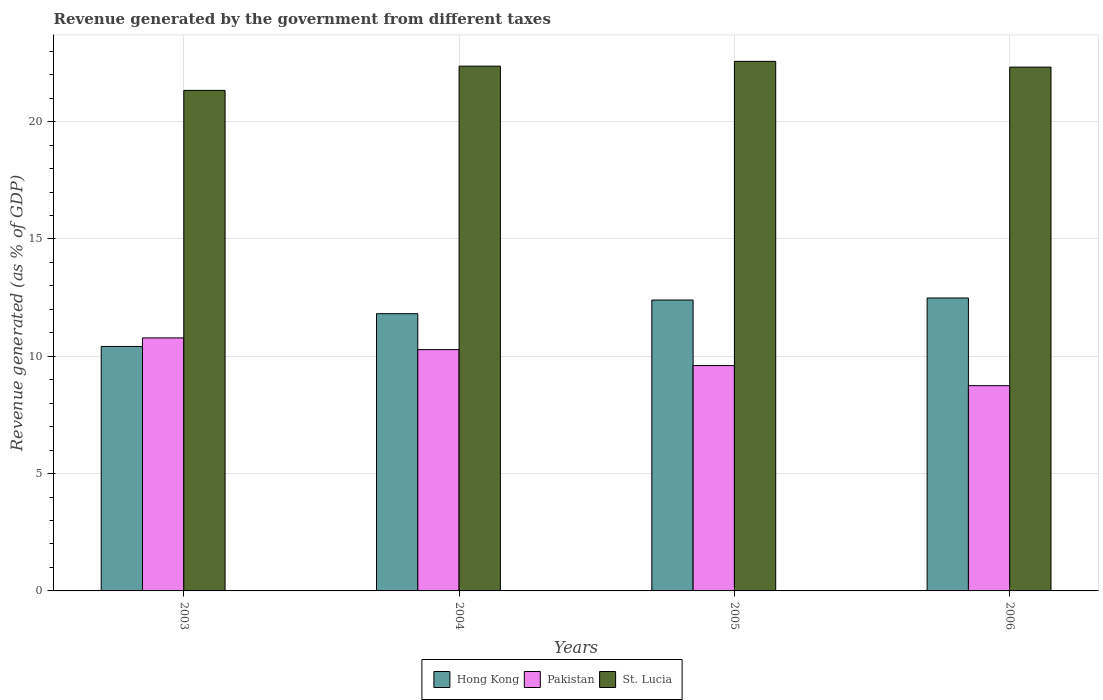Are the number of bars per tick equal to the number of legend labels?
Provide a succinct answer. Yes. Are the number of bars on each tick of the X-axis equal?
Give a very brief answer. Yes. How many bars are there on the 1st tick from the right?
Provide a succinct answer. 3. What is the label of the 2nd group of bars from the left?
Provide a succinct answer. 2004. In how many cases, is the number of bars for a given year not equal to the number of legend labels?
Ensure brevity in your answer.  0. What is the revenue generated by the government in Pakistan in 2003?
Keep it short and to the point. 10.78. Across all years, what is the maximum revenue generated by the government in St. Lucia?
Make the answer very short. 22.57. Across all years, what is the minimum revenue generated by the government in Pakistan?
Offer a very short reply. 8.75. In which year was the revenue generated by the government in Hong Kong maximum?
Your response must be concise. 2006. In which year was the revenue generated by the government in St. Lucia minimum?
Your answer should be very brief. 2003. What is the total revenue generated by the government in Pakistan in the graph?
Give a very brief answer. 39.42. What is the difference between the revenue generated by the government in Pakistan in 2003 and that in 2005?
Give a very brief answer. 1.18. What is the difference between the revenue generated by the government in Hong Kong in 2006 and the revenue generated by the government in Pakistan in 2004?
Offer a terse response. 2.2. What is the average revenue generated by the government in St. Lucia per year?
Provide a succinct answer. 22.15. In the year 2005, what is the difference between the revenue generated by the government in Pakistan and revenue generated by the government in St. Lucia?
Your answer should be very brief. -12.97. What is the ratio of the revenue generated by the government in St. Lucia in 2003 to that in 2005?
Provide a succinct answer. 0.95. Is the difference between the revenue generated by the government in Pakistan in 2005 and 2006 greater than the difference between the revenue generated by the government in St. Lucia in 2005 and 2006?
Offer a very short reply. Yes. What is the difference between the highest and the second highest revenue generated by the government in Hong Kong?
Keep it short and to the point. 0.09. What is the difference between the highest and the lowest revenue generated by the government in Hong Kong?
Provide a short and direct response. 2.07. In how many years, is the revenue generated by the government in Pakistan greater than the average revenue generated by the government in Pakistan taken over all years?
Offer a very short reply. 2. Is the sum of the revenue generated by the government in St. Lucia in 2004 and 2005 greater than the maximum revenue generated by the government in Pakistan across all years?
Provide a short and direct response. Yes. What does the 3rd bar from the left in 2003 represents?
Make the answer very short. St. Lucia. How many bars are there?
Provide a short and direct response. 12. Are the values on the major ticks of Y-axis written in scientific E-notation?
Your answer should be very brief. No. Does the graph contain any zero values?
Ensure brevity in your answer.  No. What is the title of the graph?
Your response must be concise. Revenue generated by the government from different taxes. Does "South Asia" appear as one of the legend labels in the graph?
Provide a succinct answer. No. What is the label or title of the Y-axis?
Your answer should be very brief. Revenue generated (as % of GDP). What is the Revenue generated (as % of GDP) of Hong Kong in 2003?
Provide a succinct answer. 10.42. What is the Revenue generated (as % of GDP) in Pakistan in 2003?
Keep it short and to the point. 10.78. What is the Revenue generated (as % of GDP) in St. Lucia in 2003?
Give a very brief answer. 21.33. What is the Revenue generated (as % of GDP) in Hong Kong in 2004?
Give a very brief answer. 11.82. What is the Revenue generated (as % of GDP) of Pakistan in 2004?
Offer a terse response. 10.28. What is the Revenue generated (as % of GDP) in St. Lucia in 2004?
Provide a succinct answer. 22.37. What is the Revenue generated (as % of GDP) of Hong Kong in 2005?
Provide a short and direct response. 12.4. What is the Revenue generated (as % of GDP) in Pakistan in 2005?
Your answer should be compact. 9.6. What is the Revenue generated (as % of GDP) in St. Lucia in 2005?
Your answer should be compact. 22.57. What is the Revenue generated (as % of GDP) of Hong Kong in 2006?
Offer a terse response. 12.49. What is the Revenue generated (as % of GDP) in Pakistan in 2006?
Offer a terse response. 8.75. What is the Revenue generated (as % of GDP) of St. Lucia in 2006?
Provide a short and direct response. 22.32. Across all years, what is the maximum Revenue generated (as % of GDP) of Hong Kong?
Your answer should be very brief. 12.49. Across all years, what is the maximum Revenue generated (as % of GDP) in Pakistan?
Provide a succinct answer. 10.78. Across all years, what is the maximum Revenue generated (as % of GDP) of St. Lucia?
Ensure brevity in your answer.  22.57. Across all years, what is the minimum Revenue generated (as % of GDP) of Hong Kong?
Your response must be concise. 10.42. Across all years, what is the minimum Revenue generated (as % of GDP) of Pakistan?
Offer a terse response. 8.75. Across all years, what is the minimum Revenue generated (as % of GDP) of St. Lucia?
Your answer should be compact. 21.33. What is the total Revenue generated (as % of GDP) in Hong Kong in the graph?
Ensure brevity in your answer.  47.12. What is the total Revenue generated (as % of GDP) in Pakistan in the graph?
Your answer should be compact. 39.42. What is the total Revenue generated (as % of GDP) of St. Lucia in the graph?
Offer a terse response. 88.59. What is the difference between the Revenue generated (as % of GDP) in Hong Kong in 2003 and that in 2004?
Give a very brief answer. -1.4. What is the difference between the Revenue generated (as % of GDP) in Pakistan in 2003 and that in 2004?
Your response must be concise. 0.5. What is the difference between the Revenue generated (as % of GDP) in St. Lucia in 2003 and that in 2004?
Your response must be concise. -1.03. What is the difference between the Revenue generated (as % of GDP) in Hong Kong in 2003 and that in 2005?
Give a very brief answer. -1.98. What is the difference between the Revenue generated (as % of GDP) in Pakistan in 2003 and that in 2005?
Your response must be concise. 1.18. What is the difference between the Revenue generated (as % of GDP) of St. Lucia in 2003 and that in 2005?
Give a very brief answer. -1.24. What is the difference between the Revenue generated (as % of GDP) in Hong Kong in 2003 and that in 2006?
Make the answer very short. -2.07. What is the difference between the Revenue generated (as % of GDP) of Pakistan in 2003 and that in 2006?
Keep it short and to the point. 2.04. What is the difference between the Revenue generated (as % of GDP) in St. Lucia in 2003 and that in 2006?
Your response must be concise. -0.99. What is the difference between the Revenue generated (as % of GDP) of Hong Kong in 2004 and that in 2005?
Provide a succinct answer. -0.58. What is the difference between the Revenue generated (as % of GDP) in Pakistan in 2004 and that in 2005?
Your answer should be compact. 0.68. What is the difference between the Revenue generated (as % of GDP) of St. Lucia in 2004 and that in 2005?
Your answer should be compact. -0.2. What is the difference between the Revenue generated (as % of GDP) in Hong Kong in 2004 and that in 2006?
Ensure brevity in your answer.  -0.67. What is the difference between the Revenue generated (as % of GDP) of Pakistan in 2004 and that in 2006?
Make the answer very short. 1.54. What is the difference between the Revenue generated (as % of GDP) in St. Lucia in 2004 and that in 2006?
Give a very brief answer. 0.04. What is the difference between the Revenue generated (as % of GDP) of Hong Kong in 2005 and that in 2006?
Make the answer very short. -0.09. What is the difference between the Revenue generated (as % of GDP) of Pakistan in 2005 and that in 2006?
Your response must be concise. 0.86. What is the difference between the Revenue generated (as % of GDP) of St. Lucia in 2005 and that in 2006?
Provide a short and direct response. 0.25. What is the difference between the Revenue generated (as % of GDP) in Hong Kong in 2003 and the Revenue generated (as % of GDP) in Pakistan in 2004?
Give a very brief answer. 0.13. What is the difference between the Revenue generated (as % of GDP) in Hong Kong in 2003 and the Revenue generated (as % of GDP) in St. Lucia in 2004?
Ensure brevity in your answer.  -11.95. What is the difference between the Revenue generated (as % of GDP) in Pakistan in 2003 and the Revenue generated (as % of GDP) in St. Lucia in 2004?
Offer a terse response. -11.58. What is the difference between the Revenue generated (as % of GDP) in Hong Kong in 2003 and the Revenue generated (as % of GDP) in Pakistan in 2005?
Your response must be concise. 0.81. What is the difference between the Revenue generated (as % of GDP) of Hong Kong in 2003 and the Revenue generated (as % of GDP) of St. Lucia in 2005?
Ensure brevity in your answer.  -12.15. What is the difference between the Revenue generated (as % of GDP) of Pakistan in 2003 and the Revenue generated (as % of GDP) of St. Lucia in 2005?
Ensure brevity in your answer.  -11.79. What is the difference between the Revenue generated (as % of GDP) of Hong Kong in 2003 and the Revenue generated (as % of GDP) of Pakistan in 2006?
Keep it short and to the point. 1.67. What is the difference between the Revenue generated (as % of GDP) of Hong Kong in 2003 and the Revenue generated (as % of GDP) of St. Lucia in 2006?
Provide a succinct answer. -11.91. What is the difference between the Revenue generated (as % of GDP) in Pakistan in 2003 and the Revenue generated (as % of GDP) in St. Lucia in 2006?
Offer a terse response. -11.54. What is the difference between the Revenue generated (as % of GDP) of Hong Kong in 2004 and the Revenue generated (as % of GDP) of Pakistan in 2005?
Your answer should be very brief. 2.21. What is the difference between the Revenue generated (as % of GDP) in Hong Kong in 2004 and the Revenue generated (as % of GDP) in St. Lucia in 2005?
Offer a very short reply. -10.75. What is the difference between the Revenue generated (as % of GDP) of Pakistan in 2004 and the Revenue generated (as % of GDP) of St. Lucia in 2005?
Provide a short and direct response. -12.29. What is the difference between the Revenue generated (as % of GDP) in Hong Kong in 2004 and the Revenue generated (as % of GDP) in Pakistan in 2006?
Offer a very short reply. 3.07. What is the difference between the Revenue generated (as % of GDP) of Hong Kong in 2004 and the Revenue generated (as % of GDP) of St. Lucia in 2006?
Your answer should be compact. -10.51. What is the difference between the Revenue generated (as % of GDP) in Pakistan in 2004 and the Revenue generated (as % of GDP) in St. Lucia in 2006?
Give a very brief answer. -12.04. What is the difference between the Revenue generated (as % of GDP) of Hong Kong in 2005 and the Revenue generated (as % of GDP) of Pakistan in 2006?
Keep it short and to the point. 3.65. What is the difference between the Revenue generated (as % of GDP) of Hong Kong in 2005 and the Revenue generated (as % of GDP) of St. Lucia in 2006?
Offer a very short reply. -9.93. What is the difference between the Revenue generated (as % of GDP) in Pakistan in 2005 and the Revenue generated (as % of GDP) in St. Lucia in 2006?
Provide a succinct answer. -12.72. What is the average Revenue generated (as % of GDP) in Hong Kong per year?
Offer a terse response. 11.78. What is the average Revenue generated (as % of GDP) of Pakistan per year?
Your answer should be compact. 9.86. What is the average Revenue generated (as % of GDP) of St. Lucia per year?
Keep it short and to the point. 22.15. In the year 2003, what is the difference between the Revenue generated (as % of GDP) of Hong Kong and Revenue generated (as % of GDP) of Pakistan?
Keep it short and to the point. -0.36. In the year 2003, what is the difference between the Revenue generated (as % of GDP) in Hong Kong and Revenue generated (as % of GDP) in St. Lucia?
Give a very brief answer. -10.91. In the year 2003, what is the difference between the Revenue generated (as % of GDP) of Pakistan and Revenue generated (as % of GDP) of St. Lucia?
Offer a very short reply. -10.55. In the year 2004, what is the difference between the Revenue generated (as % of GDP) of Hong Kong and Revenue generated (as % of GDP) of Pakistan?
Make the answer very short. 1.53. In the year 2004, what is the difference between the Revenue generated (as % of GDP) in Hong Kong and Revenue generated (as % of GDP) in St. Lucia?
Provide a short and direct response. -10.55. In the year 2004, what is the difference between the Revenue generated (as % of GDP) in Pakistan and Revenue generated (as % of GDP) in St. Lucia?
Your response must be concise. -12.08. In the year 2005, what is the difference between the Revenue generated (as % of GDP) of Hong Kong and Revenue generated (as % of GDP) of Pakistan?
Your response must be concise. 2.79. In the year 2005, what is the difference between the Revenue generated (as % of GDP) of Hong Kong and Revenue generated (as % of GDP) of St. Lucia?
Make the answer very short. -10.17. In the year 2005, what is the difference between the Revenue generated (as % of GDP) of Pakistan and Revenue generated (as % of GDP) of St. Lucia?
Your answer should be very brief. -12.97. In the year 2006, what is the difference between the Revenue generated (as % of GDP) in Hong Kong and Revenue generated (as % of GDP) in Pakistan?
Give a very brief answer. 3.74. In the year 2006, what is the difference between the Revenue generated (as % of GDP) of Hong Kong and Revenue generated (as % of GDP) of St. Lucia?
Ensure brevity in your answer.  -9.84. In the year 2006, what is the difference between the Revenue generated (as % of GDP) of Pakistan and Revenue generated (as % of GDP) of St. Lucia?
Give a very brief answer. -13.58. What is the ratio of the Revenue generated (as % of GDP) in Hong Kong in 2003 to that in 2004?
Your response must be concise. 0.88. What is the ratio of the Revenue generated (as % of GDP) of Pakistan in 2003 to that in 2004?
Your answer should be compact. 1.05. What is the ratio of the Revenue generated (as % of GDP) in St. Lucia in 2003 to that in 2004?
Your answer should be compact. 0.95. What is the ratio of the Revenue generated (as % of GDP) in Hong Kong in 2003 to that in 2005?
Offer a terse response. 0.84. What is the ratio of the Revenue generated (as % of GDP) of Pakistan in 2003 to that in 2005?
Offer a terse response. 1.12. What is the ratio of the Revenue generated (as % of GDP) in St. Lucia in 2003 to that in 2005?
Give a very brief answer. 0.95. What is the ratio of the Revenue generated (as % of GDP) of Hong Kong in 2003 to that in 2006?
Your answer should be compact. 0.83. What is the ratio of the Revenue generated (as % of GDP) of Pakistan in 2003 to that in 2006?
Your answer should be compact. 1.23. What is the ratio of the Revenue generated (as % of GDP) of St. Lucia in 2003 to that in 2006?
Your answer should be very brief. 0.96. What is the ratio of the Revenue generated (as % of GDP) of Hong Kong in 2004 to that in 2005?
Your answer should be compact. 0.95. What is the ratio of the Revenue generated (as % of GDP) in Pakistan in 2004 to that in 2005?
Provide a succinct answer. 1.07. What is the ratio of the Revenue generated (as % of GDP) of St. Lucia in 2004 to that in 2005?
Offer a terse response. 0.99. What is the ratio of the Revenue generated (as % of GDP) in Hong Kong in 2004 to that in 2006?
Keep it short and to the point. 0.95. What is the ratio of the Revenue generated (as % of GDP) in Pakistan in 2004 to that in 2006?
Your response must be concise. 1.18. What is the ratio of the Revenue generated (as % of GDP) in St. Lucia in 2004 to that in 2006?
Offer a terse response. 1. What is the ratio of the Revenue generated (as % of GDP) of Hong Kong in 2005 to that in 2006?
Offer a very short reply. 0.99. What is the ratio of the Revenue generated (as % of GDP) in Pakistan in 2005 to that in 2006?
Provide a succinct answer. 1.1. What is the difference between the highest and the second highest Revenue generated (as % of GDP) of Hong Kong?
Offer a terse response. 0.09. What is the difference between the highest and the second highest Revenue generated (as % of GDP) in Pakistan?
Your response must be concise. 0.5. What is the difference between the highest and the second highest Revenue generated (as % of GDP) in St. Lucia?
Provide a succinct answer. 0.2. What is the difference between the highest and the lowest Revenue generated (as % of GDP) in Hong Kong?
Provide a short and direct response. 2.07. What is the difference between the highest and the lowest Revenue generated (as % of GDP) in Pakistan?
Your answer should be very brief. 2.04. What is the difference between the highest and the lowest Revenue generated (as % of GDP) in St. Lucia?
Provide a succinct answer. 1.24. 